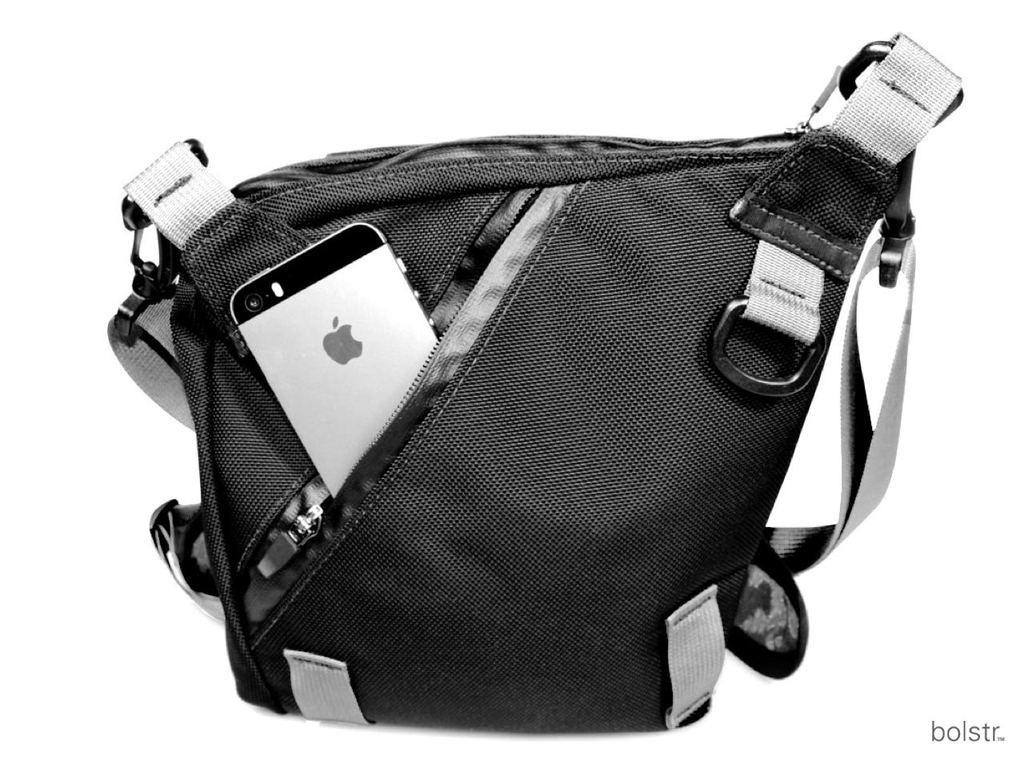What type of object is in the image? The object in the image is an iPhone. What color is the back of the iPhone? The iPhone has a black color back. Where is the playground located in the image? There is no playground present in the image; it features an iPhone with a black back. 